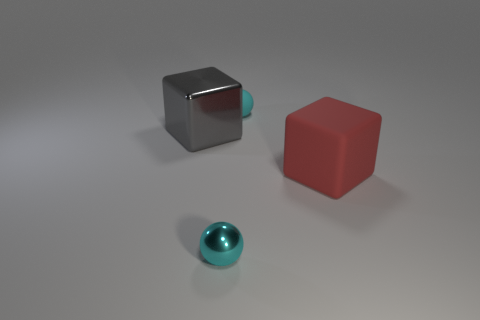There is a small thing in front of the large red rubber object; is it the same color as the rubber ball?
Provide a succinct answer. Yes. There is a metallic thing that is the same shape as the tiny cyan matte thing; what is its size?
Ensure brevity in your answer.  Small. Are there any other things that are the same size as the cyan metal sphere?
Provide a short and direct response. Yes. What material is the cyan object in front of the small cyan object behind the metallic object in front of the large red rubber cube made of?
Offer a very short reply. Metal. Are there more large cubes on the right side of the big gray shiny block than small cyan balls behind the cyan rubber object?
Make the answer very short. Yes. Does the gray cube have the same size as the red rubber thing?
Your response must be concise. Yes. There is another large thing that is the same shape as the gray shiny object; what color is it?
Ensure brevity in your answer.  Red. What number of objects have the same color as the small rubber ball?
Your answer should be very brief. 1. Is the number of large red things behind the large red cube greater than the number of cubes?
Make the answer very short. No. The tiny metal ball that is in front of the block that is to the left of the small matte thing is what color?
Your answer should be very brief. Cyan. 